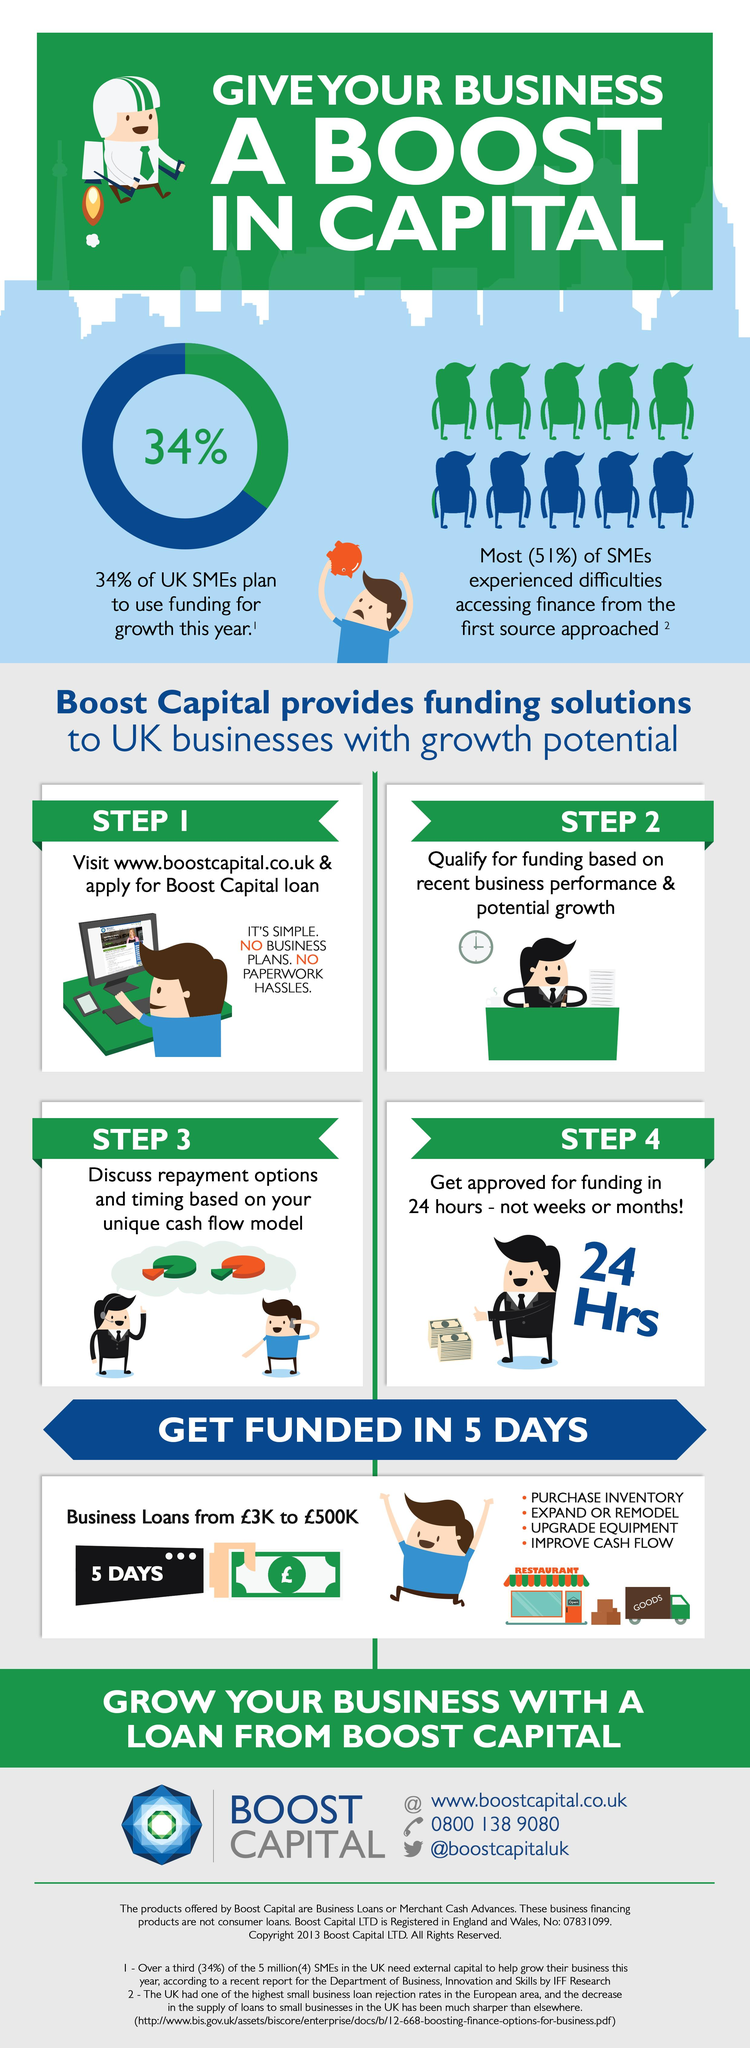Specify some key components in this picture. Boost Capital considers recent business performance and potential for growth as the criteria for approving business loans. According to a recent study, a significant 51% of small to medium enterprises in the UK faced challenges in obtaining loans from financial institutions other than Boost Capital. Boost Capital will credit the loan amount in cash within 5 days. 